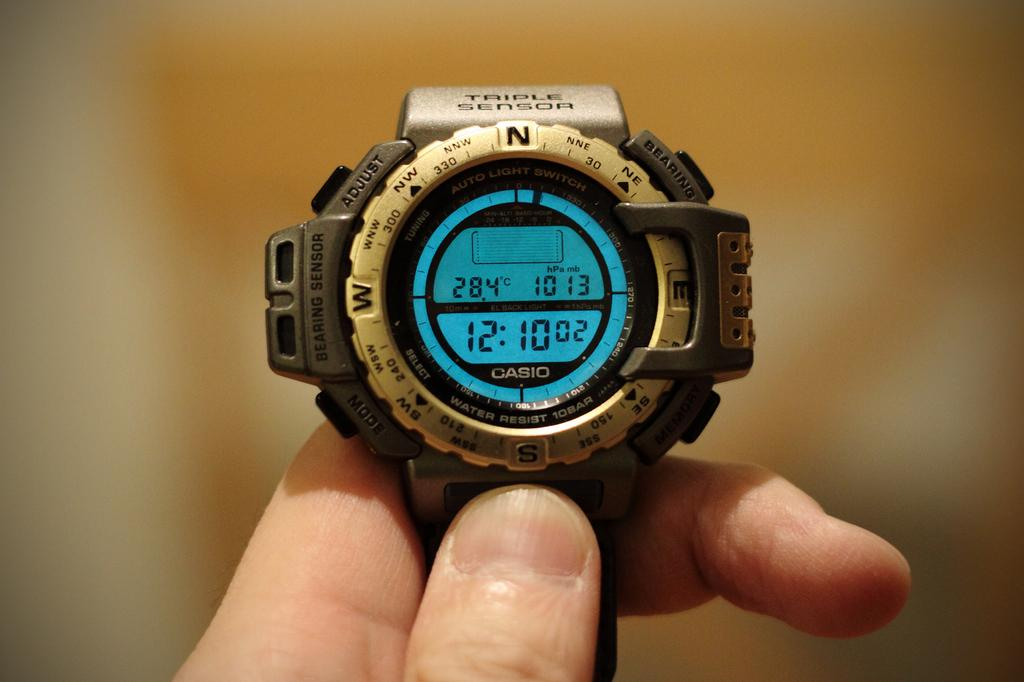<image>
Present a compact description of the photo's key features. A indigo watch has the words AUTO LITGHT SWITCH printed on its face 